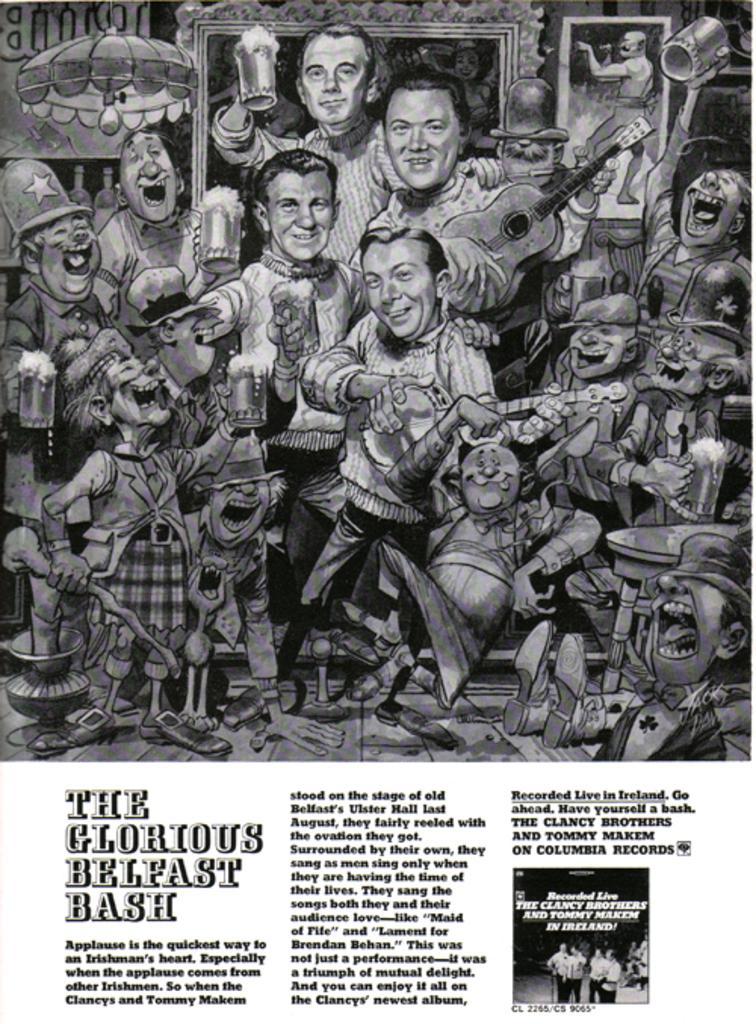Can you describe this image briefly? Here we can see poster, in this poster we can see people and this person holding guitar. 